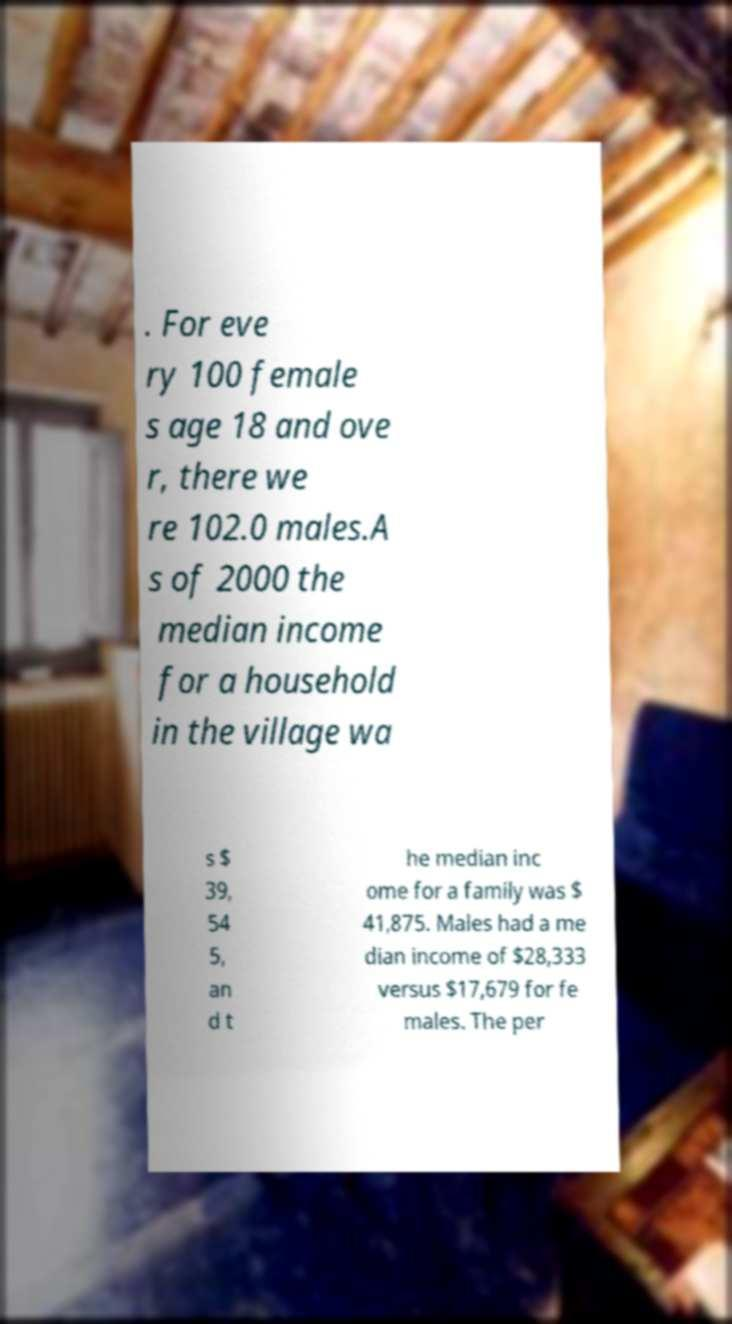For documentation purposes, I need the text within this image transcribed. Could you provide that? . For eve ry 100 female s age 18 and ove r, there we re 102.0 males.A s of 2000 the median income for a household in the village wa s $ 39, 54 5, an d t he median inc ome for a family was $ 41,875. Males had a me dian income of $28,333 versus $17,679 for fe males. The per 